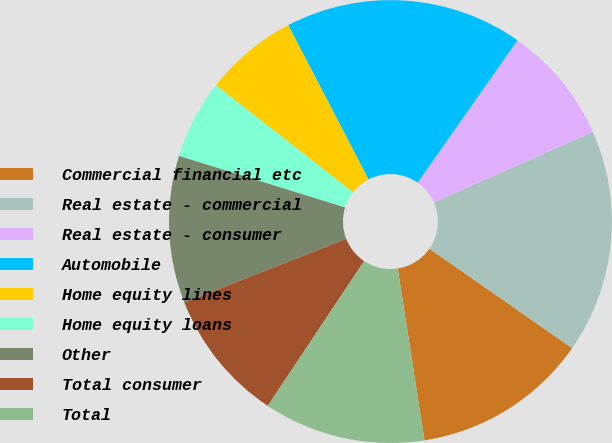Convert chart to OTSL. <chart><loc_0><loc_0><loc_500><loc_500><pie_chart><fcel>Commercial financial etc<fcel>Real estate - commercial<fcel>Real estate - consumer<fcel>Automobile<fcel>Home equity lines<fcel>Home equity loans<fcel>Other<fcel>Total consumer<fcel>Total<nl><fcel>12.86%<fcel>16.31%<fcel>8.64%<fcel>17.37%<fcel>6.81%<fcel>5.76%<fcel>10.75%<fcel>9.69%<fcel>11.8%<nl></chart> 